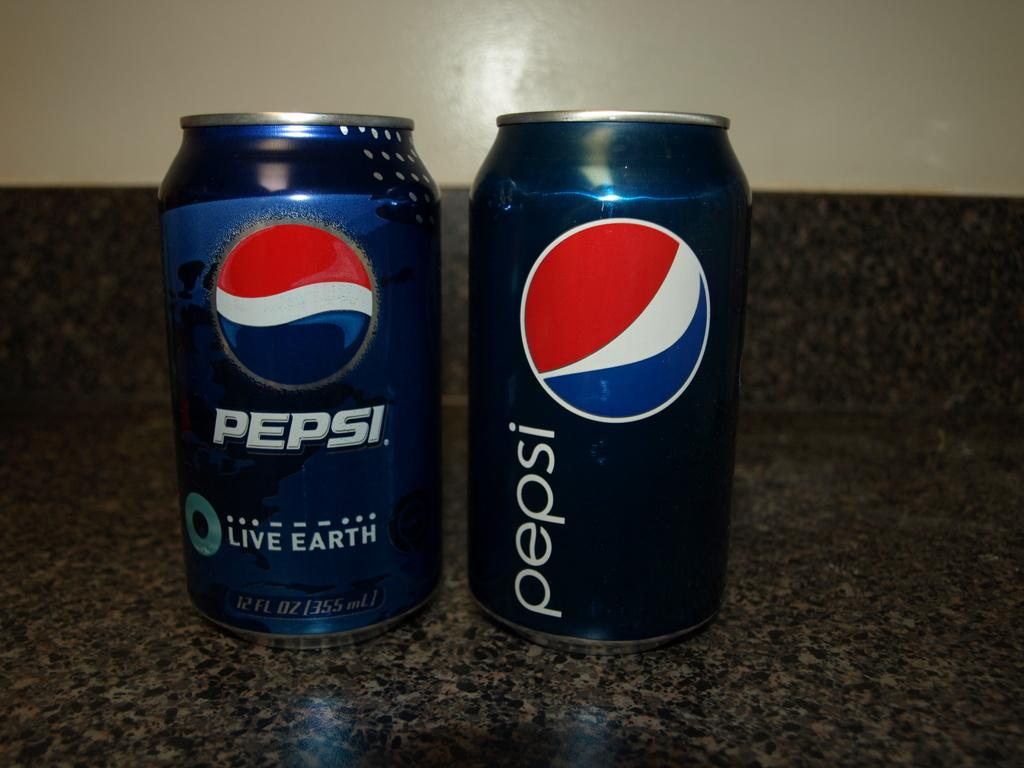<image>
Give a short and clear explanation of the subsequent image. A can of regular pepsi and a can of pepsi live earth. 